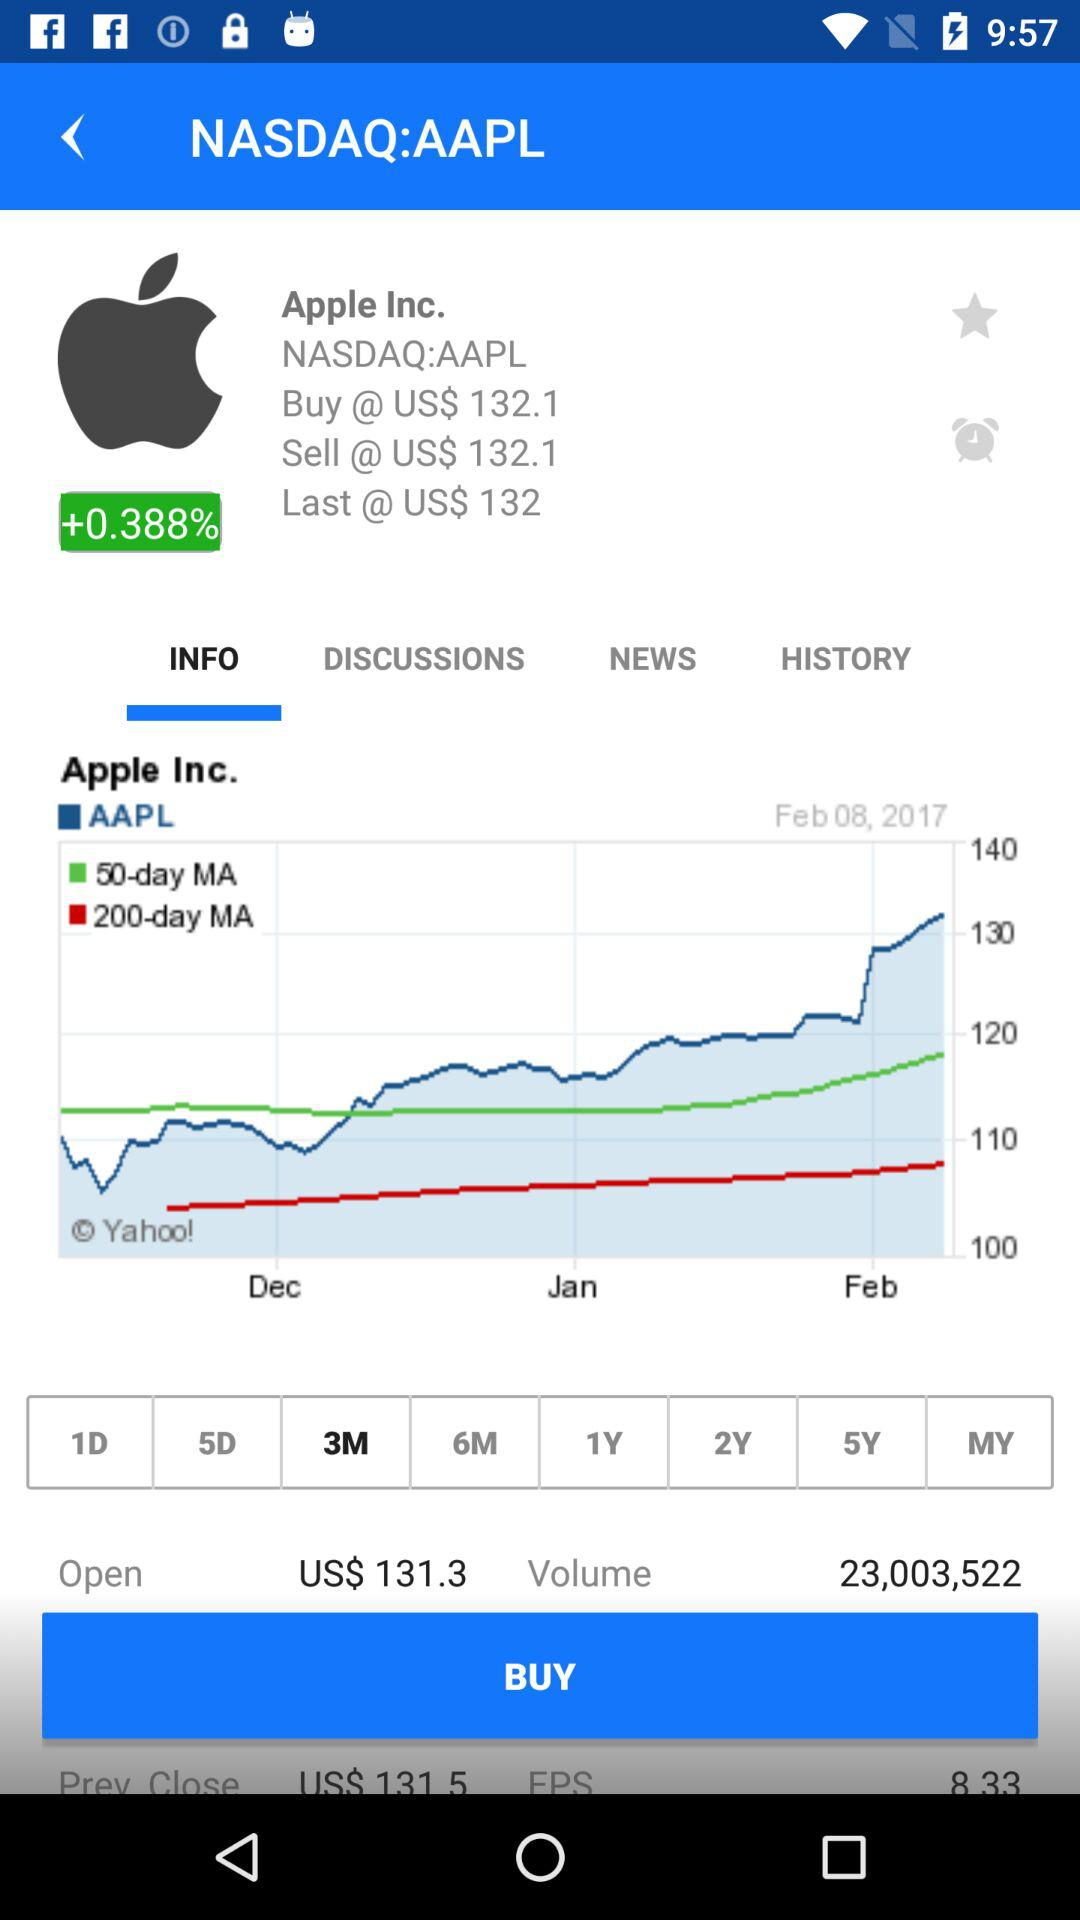What is the last price of the stock? The last price of the stock is US$ 132. 